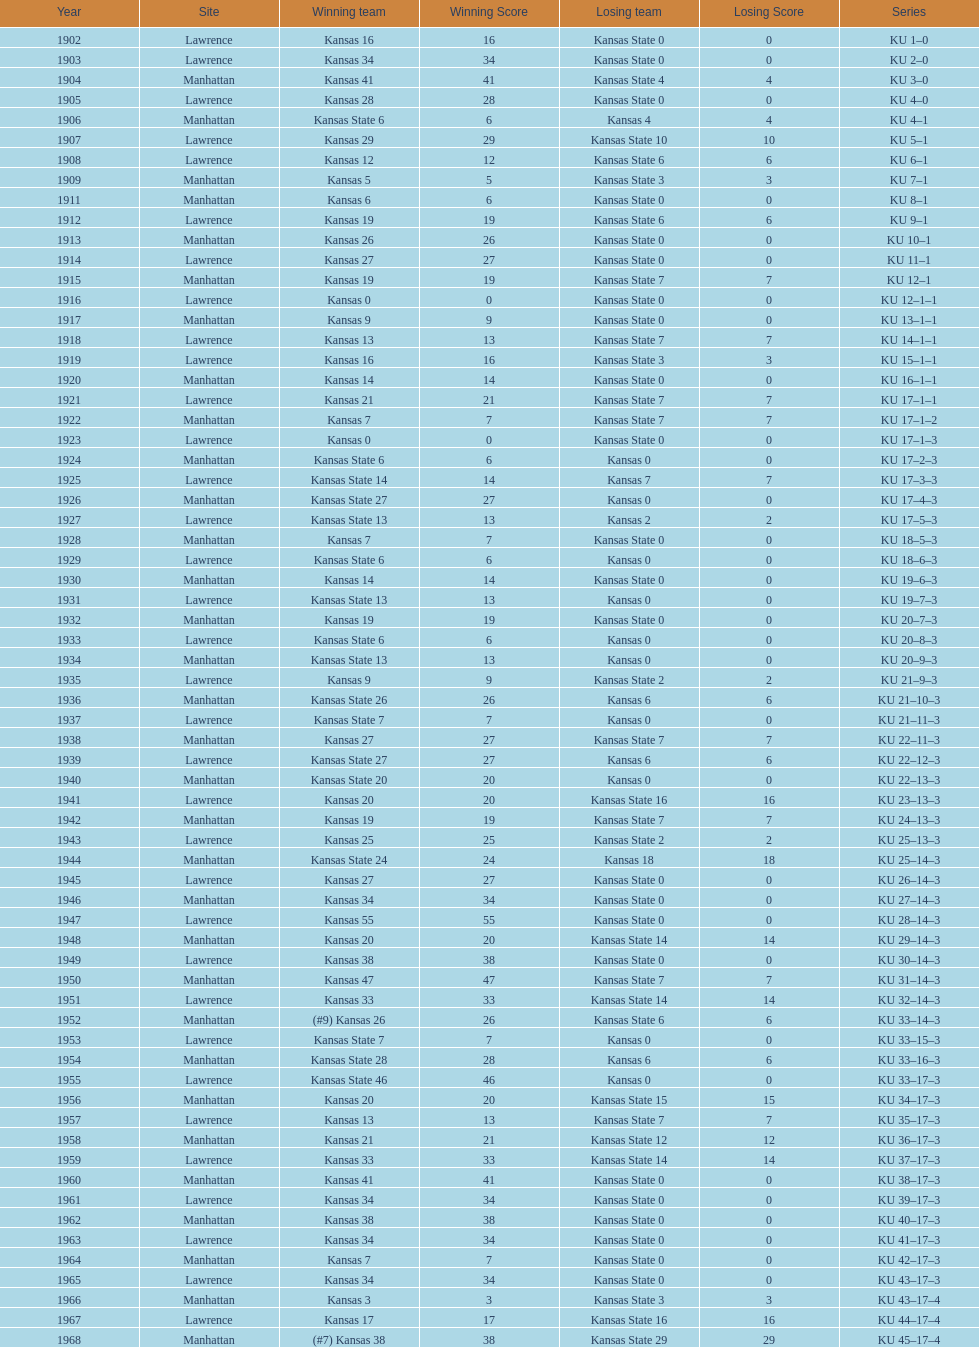Write the full table. {'header': ['Year', 'Site', 'Winning team', 'Winning Score', 'Losing team', 'Losing Score', 'Series'], 'rows': [['1902', 'Lawrence', 'Kansas 16', '16', 'Kansas State 0', '0', 'KU 1–0'], ['1903', 'Lawrence', 'Kansas 34', '34', 'Kansas State 0', '0', 'KU 2–0'], ['1904', 'Manhattan', 'Kansas 41', '41', 'Kansas State 4', '4', 'KU 3–0'], ['1905', 'Lawrence', 'Kansas 28', '28', 'Kansas State 0', '0', 'KU 4–0'], ['1906', 'Manhattan', 'Kansas State 6', '6', 'Kansas 4', '4', 'KU 4–1'], ['1907', 'Lawrence', 'Kansas 29', '29', 'Kansas State 10', '10', 'KU 5–1'], ['1908', 'Lawrence', 'Kansas 12', '12', 'Kansas State 6', '6', 'KU 6–1'], ['1909', 'Manhattan', 'Kansas 5', '5', 'Kansas State 3', '3', 'KU 7–1'], ['1911', 'Manhattan', 'Kansas 6', '6', 'Kansas State 0', '0', 'KU 8–1'], ['1912', 'Lawrence', 'Kansas 19', '19', 'Kansas State 6', '6', 'KU 9–1'], ['1913', 'Manhattan', 'Kansas 26', '26', 'Kansas State 0', '0', 'KU 10–1'], ['1914', 'Lawrence', 'Kansas 27', '27', 'Kansas State 0', '0', 'KU 11–1'], ['1915', 'Manhattan', 'Kansas 19', '19', 'Kansas State 7', '7', 'KU 12–1'], ['1916', 'Lawrence', 'Kansas 0', '0', 'Kansas State 0', '0', 'KU 12–1–1'], ['1917', 'Manhattan', 'Kansas 9', '9', 'Kansas State 0', '0', 'KU 13–1–1'], ['1918', 'Lawrence', 'Kansas 13', '13', 'Kansas State 7', '7', 'KU 14–1–1'], ['1919', 'Lawrence', 'Kansas 16', '16', 'Kansas State 3', '3', 'KU 15–1–1'], ['1920', 'Manhattan', 'Kansas 14', '14', 'Kansas State 0', '0', 'KU 16–1–1'], ['1921', 'Lawrence', 'Kansas 21', '21', 'Kansas State 7', '7', 'KU 17–1–1'], ['1922', 'Manhattan', 'Kansas 7', '7', 'Kansas State 7', '7', 'KU 17–1–2'], ['1923', 'Lawrence', 'Kansas 0', '0', 'Kansas State 0', '0', 'KU 17–1–3'], ['1924', 'Manhattan', 'Kansas State 6', '6', 'Kansas 0', '0', 'KU 17–2–3'], ['1925', 'Lawrence', 'Kansas State 14', '14', 'Kansas 7', '7', 'KU 17–3–3'], ['1926', 'Manhattan', 'Kansas State 27', '27', 'Kansas 0', '0', 'KU 17–4–3'], ['1927', 'Lawrence', 'Kansas State 13', '13', 'Kansas 2', '2', 'KU 17–5–3'], ['1928', 'Manhattan', 'Kansas 7', '7', 'Kansas State 0', '0', 'KU 18–5–3'], ['1929', 'Lawrence', 'Kansas State 6', '6', 'Kansas 0', '0', 'KU 18–6–3'], ['1930', 'Manhattan', 'Kansas 14', '14', 'Kansas State 0', '0', 'KU 19–6–3'], ['1931', 'Lawrence', 'Kansas State 13', '13', 'Kansas 0', '0', 'KU 19–7–3'], ['1932', 'Manhattan', 'Kansas 19', '19', 'Kansas State 0', '0', 'KU 20–7–3'], ['1933', 'Lawrence', 'Kansas State 6', '6', 'Kansas 0', '0', 'KU 20–8–3'], ['1934', 'Manhattan', 'Kansas State 13', '13', 'Kansas 0', '0', 'KU 20–9–3'], ['1935', 'Lawrence', 'Kansas 9', '9', 'Kansas State 2', '2', 'KU 21–9–3'], ['1936', 'Manhattan', 'Kansas State 26', '26', 'Kansas 6', '6', 'KU 21–10–3'], ['1937', 'Lawrence', 'Kansas State 7', '7', 'Kansas 0', '0', 'KU 21–11–3'], ['1938', 'Manhattan', 'Kansas 27', '27', 'Kansas State 7', '7', 'KU 22–11–3'], ['1939', 'Lawrence', 'Kansas State 27', '27', 'Kansas 6', '6', 'KU 22–12–3'], ['1940', 'Manhattan', 'Kansas State 20', '20', 'Kansas 0', '0', 'KU 22–13–3'], ['1941', 'Lawrence', 'Kansas 20', '20', 'Kansas State 16', '16', 'KU 23–13–3'], ['1942', 'Manhattan', 'Kansas 19', '19', 'Kansas State 7', '7', 'KU 24–13–3'], ['1943', 'Lawrence', 'Kansas 25', '25', 'Kansas State 2', '2', 'KU 25–13–3'], ['1944', 'Manhattan', 'Kansas State 24', '24', 'Kansas 18', '18', 'KU 25–14–3'], ['1945', 'Lawrence', 'Kansas 27', '27', 'Kansas State 0', '0', 'KU 26–14–3'], ['1946', 'Manhattan', 'Kansas 34', '34', 'Kansas State 0', '0', 'KU 27–14–3'], ['1947', 'Lawrence', 'Kansas 55', '55', 'Kansas State 0', '0', 'KU 28–14–3'], ['1948', 'Manhattan', 'Kansas 20', '20', 'Kansas State 14', '14', 'KU 29–14–3'], ['1949', 'Lawrence', 'Kansas 38', '38', 'Kansas State 0', '0', 'KU 30–14–3'], ['1950', 'Manhattan', 'Kansas 47', '47', 'Kansas State 7', '7', 'KU 31–14–3'], ['1951', 'Lawrence', 'Kansas 33', '33', 'Kansas State 14', '14', 'KU 32–14–3'], ['1952', 'Manhattan', '(#9) Kansas 26', '26', 'Kansas State 6', '6', 'KU 33–14–3'], ['1953', 'Lawrence', 'Kansas State 7', '7', 'Kansas 0', '0', 'KU 33–15–3'], ['1954', 'Manhattan', 'Kansas State 28', '28', 'Kansas 6', '6', 'KU 33–16–3'], ['1955', 'Lawrence', 'Kansas State 46', '46', 'Kansas 0', '0', 'KU 33–17–3'], ['1956', 'Manhattan', 'Kansas 20', '20', 'Kansas State 15', '15', 'KU 34–17–3'], ['1957', 'Lawrence', 'Kansas 13', '13', 'Kansas State 7', '7', 'KU 35–17–3'], ['1958', 'Manhattan', 'Kansas 21', '21', 'Kansas State 12', '12', 'KU 36–17–3'], ['1959', 'Lawrence', 'Kansas 33', '33', 'Kansas State 14', '14', 'KU 37–17–3'], ['1960', 'Manhattan', 'Kansas 41', '41', 'Kansas State 0', '0', 'KU 38–17–3'], ['1961', 'Lawrence', 'Kansas 34', '34', 'Kansas State 0', '0', 'KU 39–17–3'], ['1962', 'Manhattan', 'Kansas 38', '38', 'Kansas State 0', '0', 'KU 40–17–3'], ['1963', 'Lawrence', 'Kansas 34', '34', 'Kansas State 0', '0', 'KU 41–17–3'], ['1964', 'Manhattan', 'Kansas 7', '7', 'Kansas State 0', '0', 'KU 42–17–3'], ['1965', 'Lawrence', 'Kansas 34', '34', 'Kansas State 0', '0', 'KU 43–17–3'], ['1966', 'Manhattan', 'Kansas 3', '3', 'Kansas State 3', '3', 'KU 43–17–4'], ['1967', 'Lawrence', 'Kansas 17', '17', 'Kansas State 16', '16', 'KU 44–17–4'], ['1968', 'Manhattan', '(#7) Kansas 38', '38', 'Kansas State 29', '29', 'KU 45–17–4']]} How many times did kansas and kansas state play in lawrence from 1902-1968? 34. 